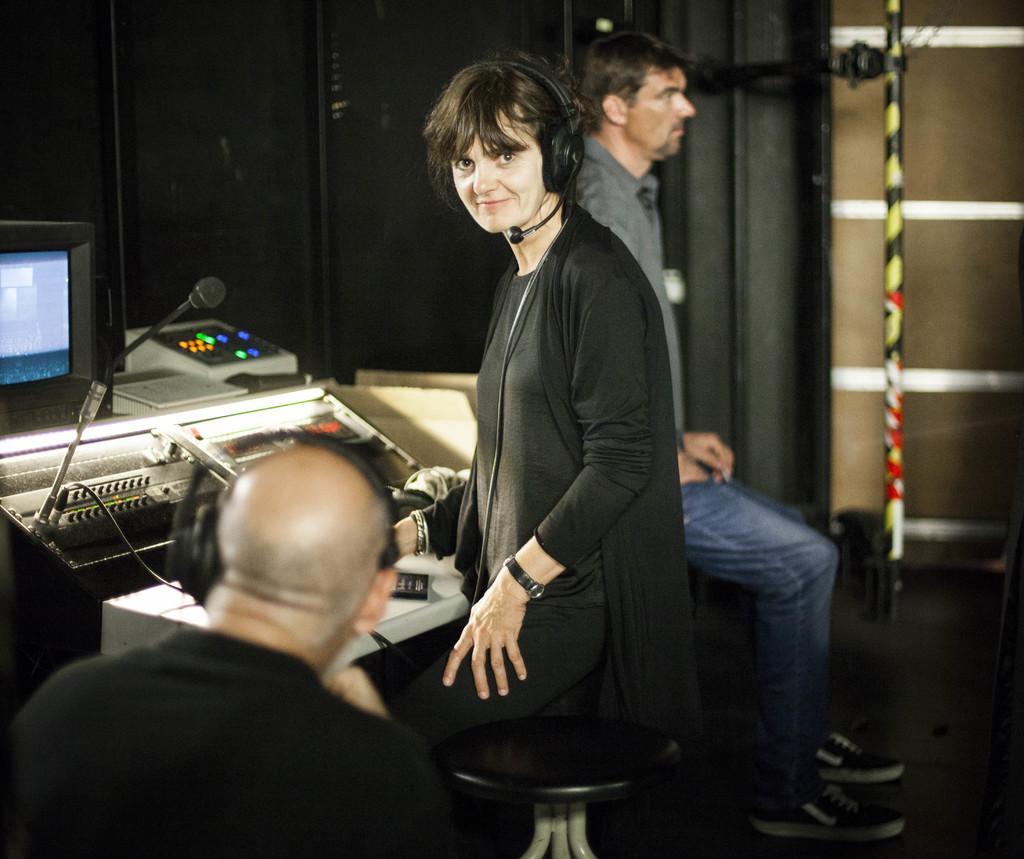In one or two sentences, can you explain what this image depicts? In this image we can see one woman standing, two people are sitting, on stool on the floor, one T. V on the table, one pole, some objects on the floor, one wall, two people wearing headsets, one microphone with stand and some objects are on the table. 